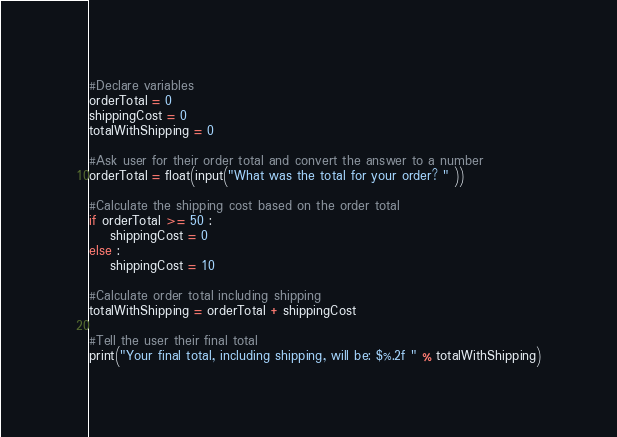<code> <loc_0><loc_0><loc_500><loc_500><_Python_>
#Declare variables
orderTotal = 0
shippingCost = 0
totalWithShipping = 0

#Ask user for their order total and convert the answer to a number
orderTotal = float(input("What was the total for your order? " ))

#Calculate the shipping cost based on the order total
if orderTotal >= 50 :
    shippingCost = 0
else :
    shippingCost = 10

#Calculate order total including shipping
totalWithShipping = orderTotal + shippingCost

#Tell the user their final total
print("Your final total, including shipping, will be: $%.2f " % totalWithShipping)





</code> 